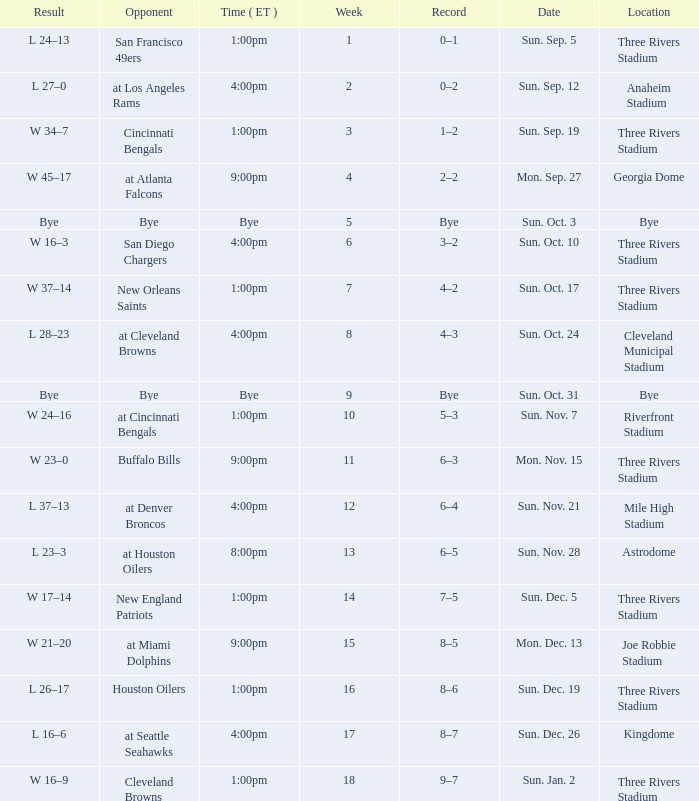What week that shows a game record of 0–1? 1.0. 